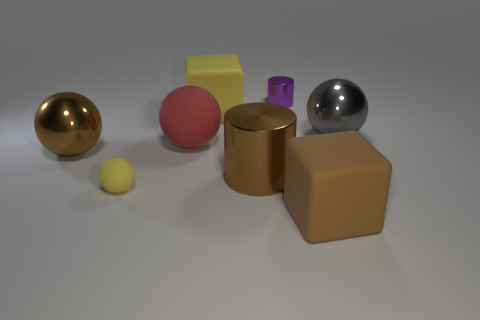Considering the different materials, can you describe how light interacts with the objects in the scene? Certainly, in the image we see objects with varying degrees of reflectiveness. The metallic spheres show clear reflections, indicating a smooth and polished surface. The rubber blocks exhibit a matte finish, diffusing light more softly across their surfaces. The differences in material properties lead to distinct visual textures and highlights. 